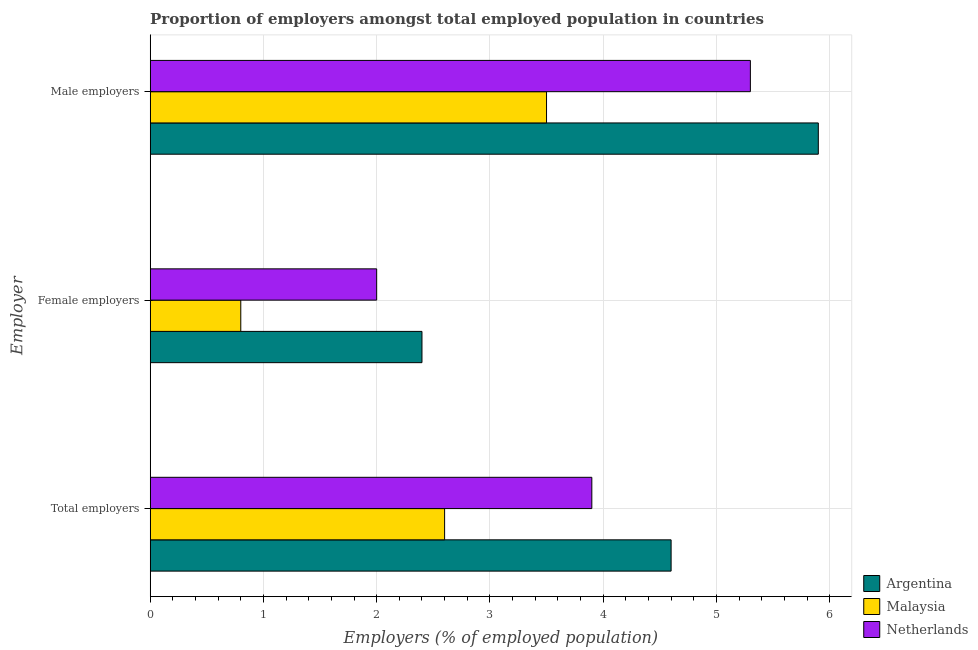How many different coloured bars are there?
Make the answer very short. 3. How many groups of bars are there?
Your response must be concise. 3. Are the number of bars per tick equal to the number of legend labels?
Give a very brief answer. Yes. Are the number of bars on each tick of the Y-axis equal?
Make the answer very short. Yes. How many bars are there on the 2nd tick from the bottom?
Your answer should be very brief. 3. What is the label of the 3rd group of bars from the top?
Offer a very short reply. Total employers. What is the percentage of male employers in Malaysia?
Provide a succinct answer. 3.5. Across all countries, what is the maximum percentage of female employers?
Your answer should be very brief. 2.4. Across all countries, what is the minimum percentage of total employers?
Offer a terse response. 2.6. In which country was the percentage of male employers maximum?
Give a very brief answer. Argentina. In which country was the percentage of male employers minimum?
Provide a succinct answer. Malaysia. What is the total percentage of total employers in the graph?
Provide a succinct answer. 11.1. What is the difference between the percentage of total employers in Netherlands and that in Malaysia?
Your answer should be very brief. 1.3. What is the difference between the percentage of total employers in Malaysia and the percentage of male employers in Argentina?
Provide a short and direct response. -3.3. What is the average percentage of female employers per country?
Offer a terse response. 1.73. What is the difference between the percentage of male employers and percentage of total employers in Netherlands?
Give a very brief answer. 1.4. In how many countries, is the percentage of female employers greater than 3.8 %?
Make the answer very short. 0. What is the ratio of the percentage of male employers in Malaysia to that in Netherlands?
Make the answer very short. 0.66. Is the percentage of female employers in Malaysia less than that in Netherlands?
Make the answer very short. Yes. Is the difference between the percentage of female employers in Malaysia and Netherlands greater than the difference between the percentage of male employers in Malaysia and Netherlands?
Your response must be concise. Yes. What is the difference between the highest and the second highest percentage of female employers?
Ensure brevity in your answer.  0.4. What is the difference between the highest and the lowest percentage of female employers?
Your answer should be very brief. 1.6. In how many countries, is the percentage of male employers greater than the average percentage of male employers taken over all countries?
Offer a very short reply. 2. Is the sum of the percentage of male employers in Malaysia and Netherlands greater than the maximum percentage of total employers across all countries?
Offer a very short reply. Yes. What does the 2nd bar from the top in Male employers represents?
Make the answer very short. Malaysia. What does the 1st bar from the bottom in Total employers represents?
Your answer should be very brief. Argentina. How many bars are there?
Your answer should be compact. 9. Are all the bars in the graph horizontal?
Your response must be concise. Yes. How many countries are there in the graph?
Provide a succinct answer. 3. What is the difference between two consecutive major ticks on the X-axis?
Offer a terse response. 1. Does the graph contain any zero values?
Offer a terse response. No. Does the graph contain grids?
Offer a terse response. Yes. How are the legend labels stacked?
Provide a short and direct response. Vertical. What is the title of the graph?
Your answer should be very brief. Proportion of employers amongst total employed population in countries. What is the label or title of the X-axis?
Your answer should be compact. Employers (% of employed population). What is the label or title of the Y-axis?
Keep it short and to the point. Employer. What is the Employers (% of employed population) in Argentina in Total employers?
Provide a succinct answer. 4.6. What is the Employers (% of employed population) in Malaysia in Total employers?
Provide a succinct answer. 2.6. What is the Employers (% of employed population) of Netherlands in Total employers?
Your response must be concise. 3.9. What is the Employers (% of employed population) in Argentina in Female employers?
Your response must be concise. 2.4. What is the Employers (% of employed population) in Malaysia in Female employers?
Your response must be concise. 0.8. What is the Employers (% of employed population) of Argentina in Male employers?
Ensure brevity in your answer.  5.9. What is the Employers (% of employed population) of Netherlands in Male employers?
Provide a succinct answer. 5.3. Across all Employer, what is the maximum Employers (% of employed population) in Argentina?
Your answer should be compact. 5.9. Across all Employer, what is the maximum Employers (% of employed population) of Malaysia?
Give a very brief answer. 3.5. Across all Employer, what is the maximum Employers (% of employed population) in Netherlands?
Keep it short and to the point. 5.3. Across all Employer, what is the minimum Employers (% of employed population) in Argentina?
Your answer should be compact. 2.4. Across all Employer, what is the minimum Employers (% of employed population) of Malaysia?
Offer a very short reply. 0.8. What is the total Employers (% of employed population) of Argentina in the graph?
Make the answer very short. 12.9. What is the total Employers (% of employed population) in Malaysia in the graph?
Offer a terse response. 6.9. What is the difference between the Employers (% of employed population) in Argentina in Total employers and that in Female employers?
Your answer should be very brief. 2.2. What is the difference between the Employers (% of employed population) of Malaysia in Total employers and that in Female employers?
Keep it short and to the point. 1.8. What is the difference between the Employers (% of employed population) of Argentina in Total employers and that in Male employers?
Your answer should be very brief. -1.3. What is the difference between the Employers (% of employed population) in Malaysia in Total employers and that in Male employers?
Provide a short and direct response. -0.9. What is the difference between the Employers (% of employed population) in Argentina in Female employers and that in Male employers?
Your answer should be very brief. -3.5. What is the difference between the Employers (% of employed population) of Malaysia in Female employers and that in Male employers?
Offer a terse response. -2.7. What is the difference between the Employers (% of employed population) of Argentina in Total employers and the Employers (% of employed population) of Malaysia in Female employers?
Offer a terse response. 3.8. What is the difference between the Employers (% of employed population) in Argentina in Total employers and the Employers (% of employed population) in Malaysia in Male employers?
Ensure brevity in your answer.  1.1. What is the difference between the Employers (% of employed population) in Argentina in Total employers and the Employers (% of employed population) in Netherlands in Male employers?
Provide a succinct answer. -0.7. What is the difference between the Employers (% of employed population) in Argentina in Female employers and the Employers (% of employed population) in Malaysia in Male employers?
Your response must be concise. -1.1. What is the difference between the Employers (% of employed population) of Argentina in Female employers and the Employers (% of employed population) of Netherlands in Male employers?
Make the answer very short. -2.9. What is the difference between the Employers (% of employed population) of Malaysia in Female employers and the Employers (% of employed population) of Netherlands in Male employers?
Your response must be concise. -4.5. What is the average Employers (% of employed population) of Malaysia per Employer?
Provide a short and direct response. 2.3. What is the average Employers (% of employed population) of Netherlands per Employer?
Provide a succinct answer. 3.73. What is the difference between the Employers (% of employed population) of Argentina and Employers (% of employed population) of Malaysia in Total employers?
Your response must be concise. 2. What is the difference between the Employers (% of employed population) in Malaysia and Employers (% of employed population) in Netherlands in Total employers?
Your response must be concise. -1.3. What is the difference between the Employers (% of employed population) in Argentina and Employers (% of employed population) in Netherlands in Male employers?
Ensure brevity in your answer.  0.6. What is the difference between the Employers (% of employed population) in Malaysia and Employers (% of employed population) in Netherlands in Male employers?
Ensure brevity in your answer.  -1.8. What is the ratio of the Employers (% of employed population) in Argentina in Total employers to that in Female employers?
Provide a succinct answer. 1.92. What is the ratio of the Employers (% of employed population) in Netherlands in Total employers to that in Female employers?
Make the answer very short. 1.95. What is the ratio of the Employers (% of employed population) in Argentina in Total employers to that in Male employers?
Your answer should be compact. 0.78. What is the ratio of the Employers (% of employed population) in Malaysia in Total employers to that in Male employers?
Offer a terse response. 0.74. What is the ratio of the Employers (% of employed population) of Netherlands in Total employers to that in Male employers?
Your response must be concise. 0.74. What is the ratio of the Employers (% of employed population) of Argentina in Female employers to that in Male employers?
Your response must be concise. 0.41. What is the ratio of the Employers (% of employed population) in Malaysia in Female employers to that in Male employers?
Offer a very short reply. 0.23. What is the ratio of the Employers (% of employed population) in Netherlands in Female employers to that in Male employers?
Offer a very short reply. 0.38. What is the difference between the highest and the lowest Employers (% of employed population) in Malaysia?
Provide a succinct answer. 2.7. 